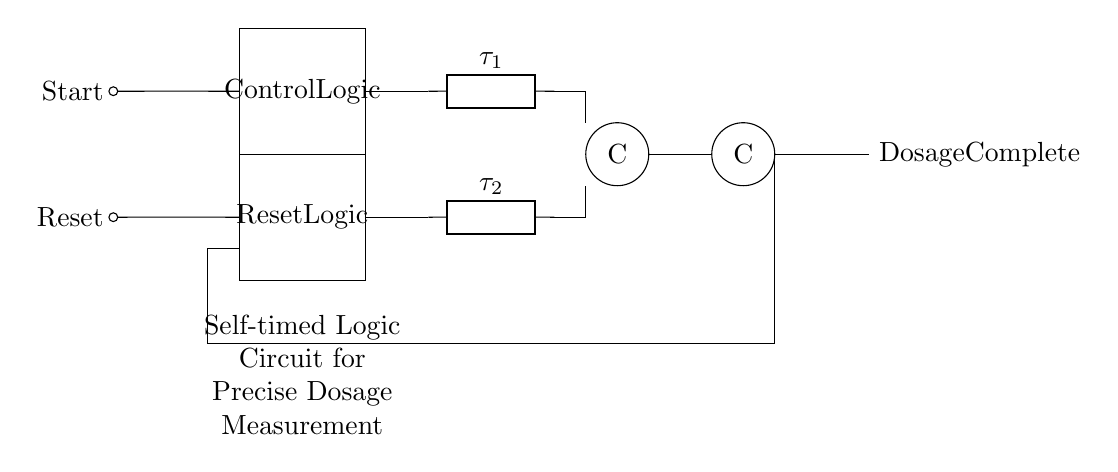What are the two main input signals? The two main input signals in the circuit are "Start" and "Reset", indicated on the left side of the diagram.
Answer: Start, Reset What type of logic elements are depicted in the circuit? The circuit includes C-elements, which are visually represented by circles labeled 'C'. These elements are used in the self-timed logic design.
Answer: C-elements How many delay elements are in the circuit? There are two delay elements present in the circuit, indicated by the generic elements labeled with tau (τ1 and τ2).
Answer: Two What is the output signal of this circuit? The output signal is labeled as "Dosage Complete" located at the right side of the circuit diagram, indicating the completion of the dosage measurement process.
Answer: Dosage Complete What does the feedback loop represent in the circuit? The feedback loop connects the output back to the Reset Logic, indicating that it is used to control the timing and state of the circuit based on the output condition.
Answer: Control timing Why is self-timed logic important in this circuit? Self-timed logic is crucial as it allows the circuit to operate independently of a clock signal, enabling precise timing for dosage measurements in drug manufacturing, which is vital for accuracy.
Answer: Precise timing 